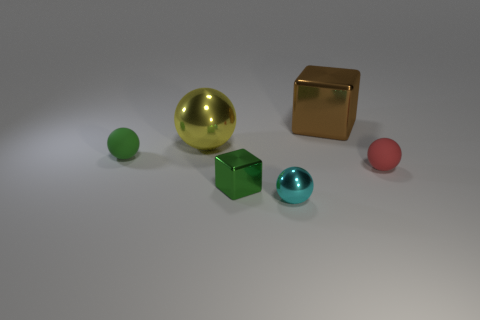Add 4 large shiny blocks. How many objects exist? 10 Subtract all small cyan balls. How many balls are left? 3 Subtract all cyan balls. How many balls are left? 3 Subtract 2 blocks. How many blocks are left? 0 Add 4 tiny cyan spheres. How many tiny cyan spheres are left? 5 Add 6 green rubber balls. How many green rubber balls exist? 7 Subtract 1 brown cubes. How many objects are left? 5 Subtract all spheres. How many objects are left? 2 Subtract all red cubes. Subtract all red cylinders. How many cubes are left? 2 Subtract all brown cylinders. How many yellow blocks are left? 0 